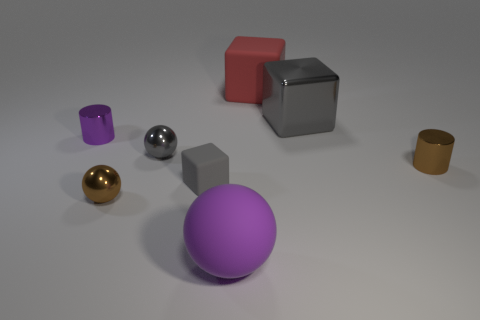What number of objects are either small metal objects or cubes that are in front of the red object?
Keep it short and to the point. 6. Is the number of brown metal cylinders that are behind the large metal block greater than the number of brown metallic balls?
Your answer should be compact. No. Are there the same number of big rubber spheres that are to the right of the gray metal block and metallic spheres in front of the brown cylinder?
Offer a terse response. No. There is a large rubber thing that is behind the tiny purple metal thing; is there a metal sphere that is right of it?
Your response must be concise. No. What is the shape of the large purple object?
Your answer should be very brief. Sphere. There is a thing that is the same color as the matte ball; what size is it?
Make the answer very short. Small. There is a brown shiny object right of the sphere that is right of the small gray metallic ball; what size is it?
Ensure brevity in your answer.  Small. What is the size of the gray rubber object on the right side of the purple metallic object?
Keep it short and to the point. Small. Is the number of small gray metallic objects in front of the tiny gray metallic thing less than the number of large purple things right of the small matte cube?
Offer a very short reply. Yes. The large shiny cube is what color?
Your answer should be very brief. Gray. 